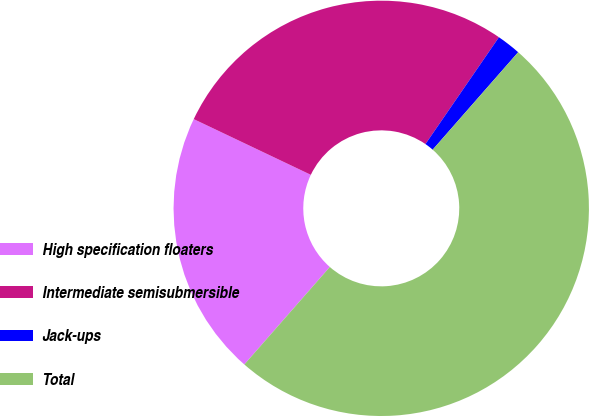Convert chart to OTSL. <chart><loc_0><loc_0><loc_500><loc_500><pie_chart><fcel>High specification floaters<fcel>Intermediate semisubmersible<fcel>Jack-ups<fcel>Total<nl><fcel>20.61%<fcel>27.52%<fcel>1.87%<fcel>50.0%<nl></chart> 